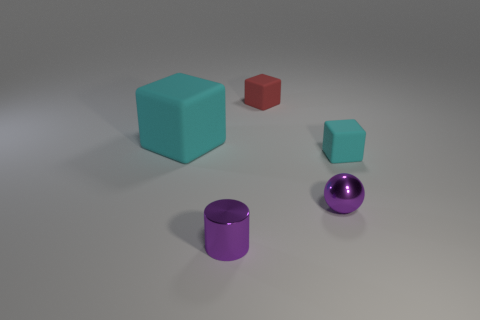Add 1 blocks. How many objects exist? 6 Subtract all balls. How many objects are left? 4 Add 1 small red cubes. How many small red cubes exist? 2 Subtract 0 cyan spheres. How many objects are left? 5 Subtract all tiny cyan rubber blocks. Subtract all big cyan cubes. How many objects are left? 3 Add 2 cyan rubber blocks. How many cyan rubber blocks are left? 4 